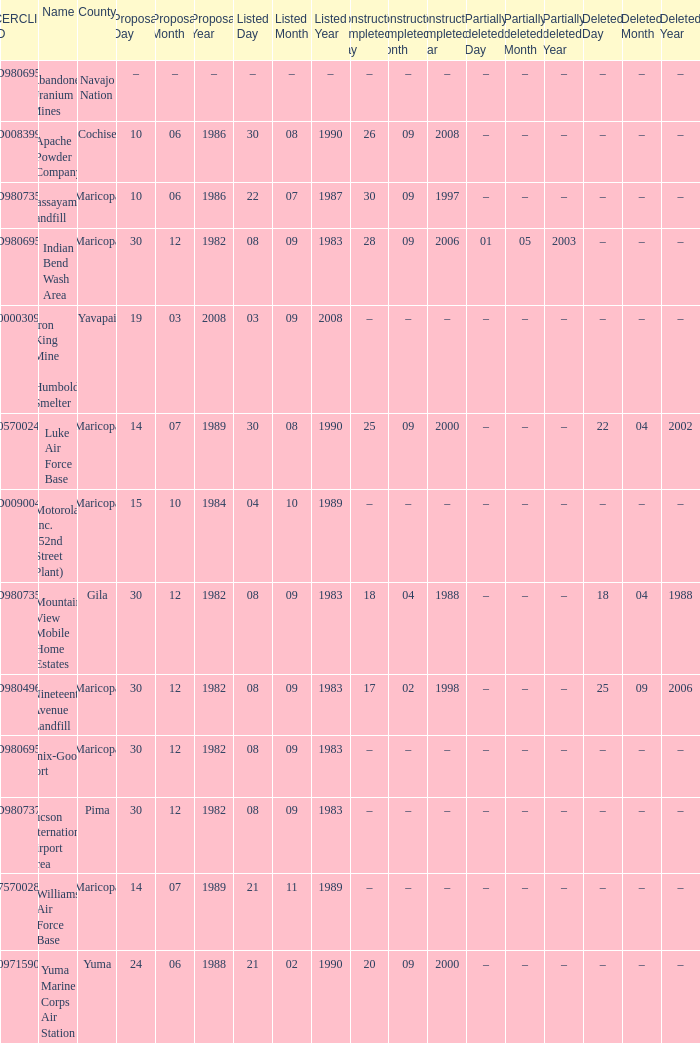What is the cerclis id when the site was proposed on 12/30/1982 and was partially deleted on 05/01/2003? AZD980695969. 